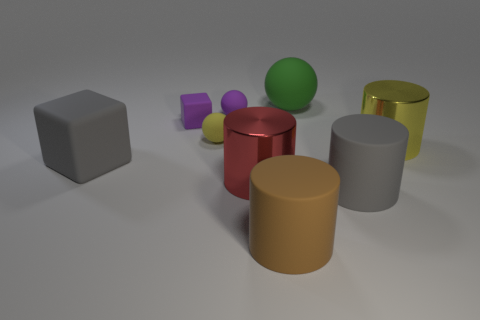Are there fewer large blue spheres than large cylinders?
Your answer should be compact. Yes. Is there a large cylinder that has the same color as the large block?
Offer a terse response. Yes. What is the shape of the big matte thing that is to the left of the big green thing and right of the tiny purple rubber block?
Provide a short and direct response. Cylinder. There is a large gray matte thing to the right of the rubber sphere in front of the purple matte cube; what shape is it?
Offer a very short reply. Cylinder. Is the large red metal object the same shape as the big brown matte object?
Provide a succinct answer. Yes. What material is the object that is the same color as the tiny cube?
Give a very brief answer. Rubber. Is the big block the same color as the big sphere?
Ensure brevity in your answer.  No. There is a matte sphere that is on the right side of the shiny thing in front of the large gray rubber cube; how many red objects are on the left side of it?
Make the answer very short. 1. There is a gray object that is the same material as the gray cylinder; what is its shape?
Your answer should be compact. Cube. What is the material of the big cylinder behind the large object left of the yellow object that is to the left of the large yellow metal thing?
Your answer should be very brief. Metal. 